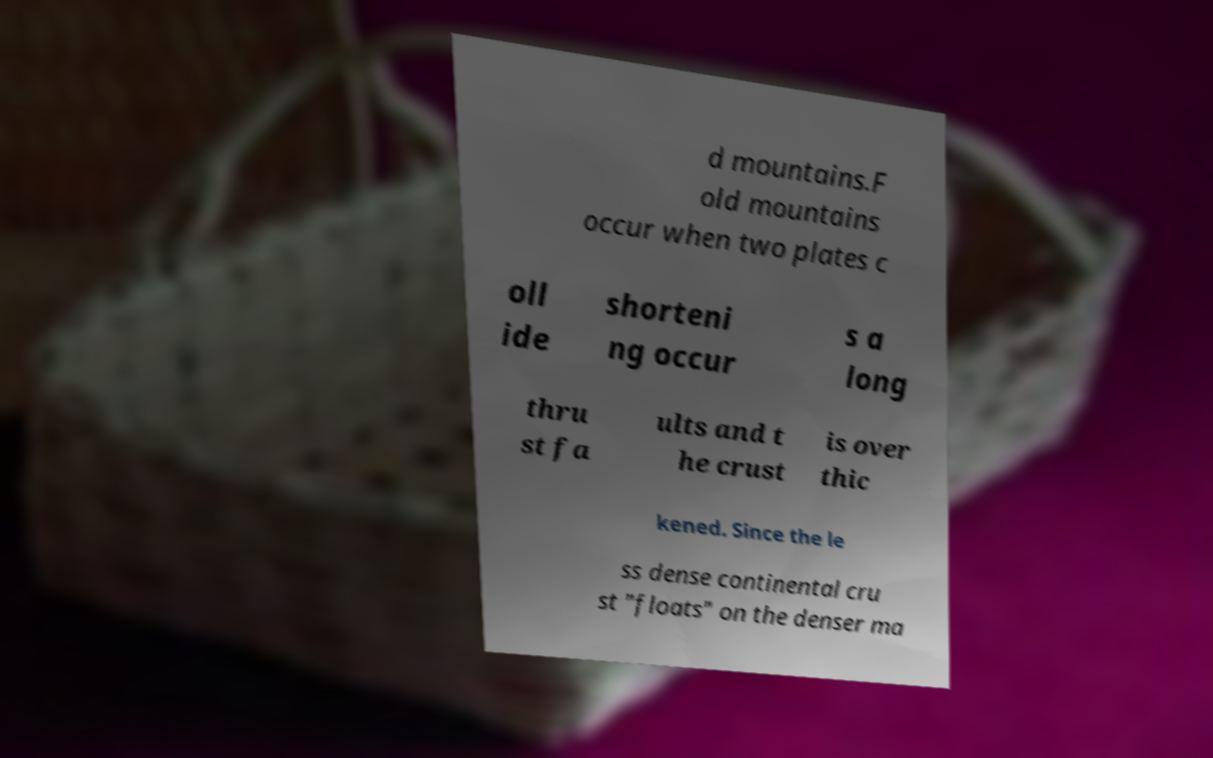There's text embedded in this image that I need extracted. Can you transcribe it verbatim? d mountains.F old mountains occur when two plates c oll ide shorteni ng occur s a long thru st fa ults and t he crust is over thic kened. Since the le ss dense continental cru st "floats" on the denser ma 